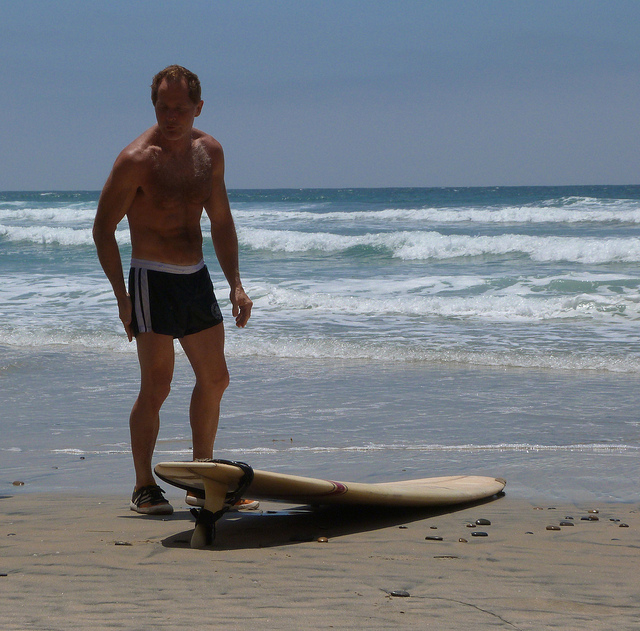Is the man wearing any accessories or specific attire related to surfing? The man is dressed in a casual, athletic manner, wearing swim shorts that are practical for surfing. The most notable accessory related to surfing is the leash strapped around his ankle, which is connected to the surfboard for safety. Imagine an alternate reality where surfboards are powered by futuristic technology. Describe how this new technology might change surfing for the man in the image. In an alternate reality, surfboards are equipped with advanced propulsion systems powered by sustainable energy. These surfboards can skim across the water at incredible speeds, using hydrodynamic fins for unparalleled maneuverability. For the man in the image, this would mean a whole new level of thrill and challenge, as he navigates through waves with the option to boost his speed. The surfboards are also equipped with an AI system that provides real-time feedback on wave conditions and suggested techniques, transforming every surfing session into an interactive learning experience. 